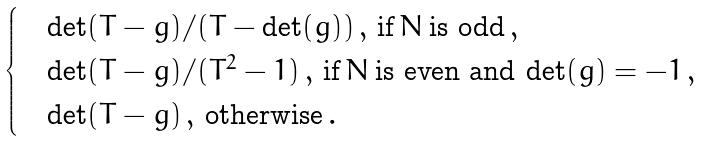<formula> <loc_0><loc_0><loc_500><loc_500>\begin{cases} & \det ( T - g ) / ( T - \det ( g ) ) \, , \, \text {if} \, N \, \text {is odd} \, , \\ & \det ( T - g ) / ( T ^ { 2 } - 1 ) \, , \, \text {if} \, N \, \text {is even and} \, \det ( g ) = - 1 \, , \\ & \det ( T - g ) \, , \, \text {otherwise} \, . \end{cases}</formula> 